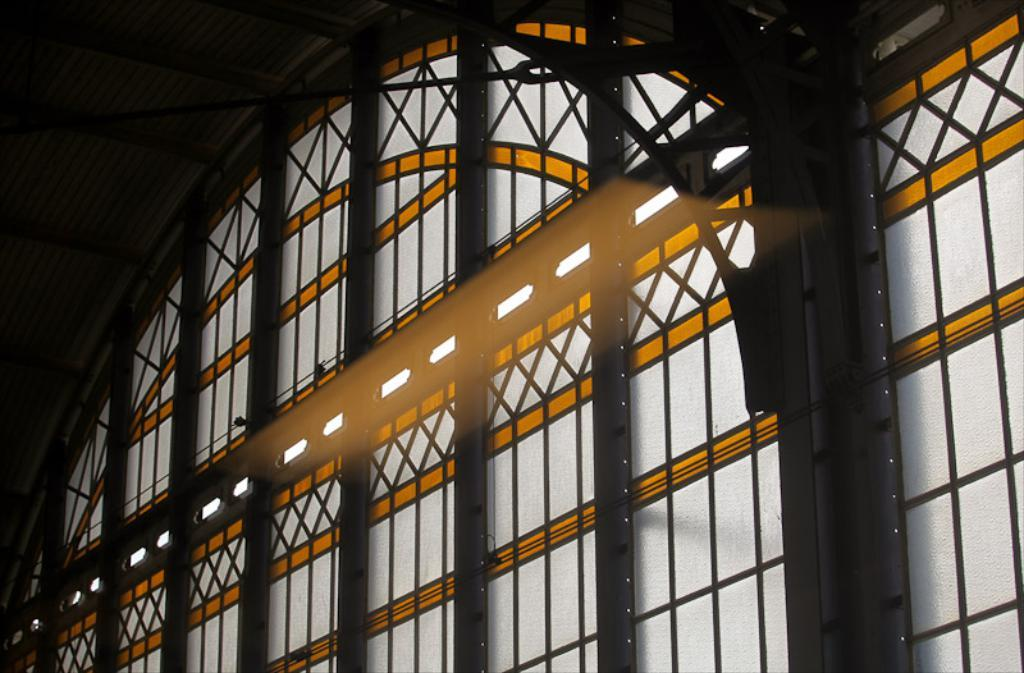What type of structure can be seen in the image? There is an iron frame in the image. What material is used for the window in the image? There is a glass window in the image. Where can the scissors be found in the image? There are no scissors present in the image. What industry is depicted in the image? The image does not depict any specific industry; it only shows an iron frame and a glass window. 